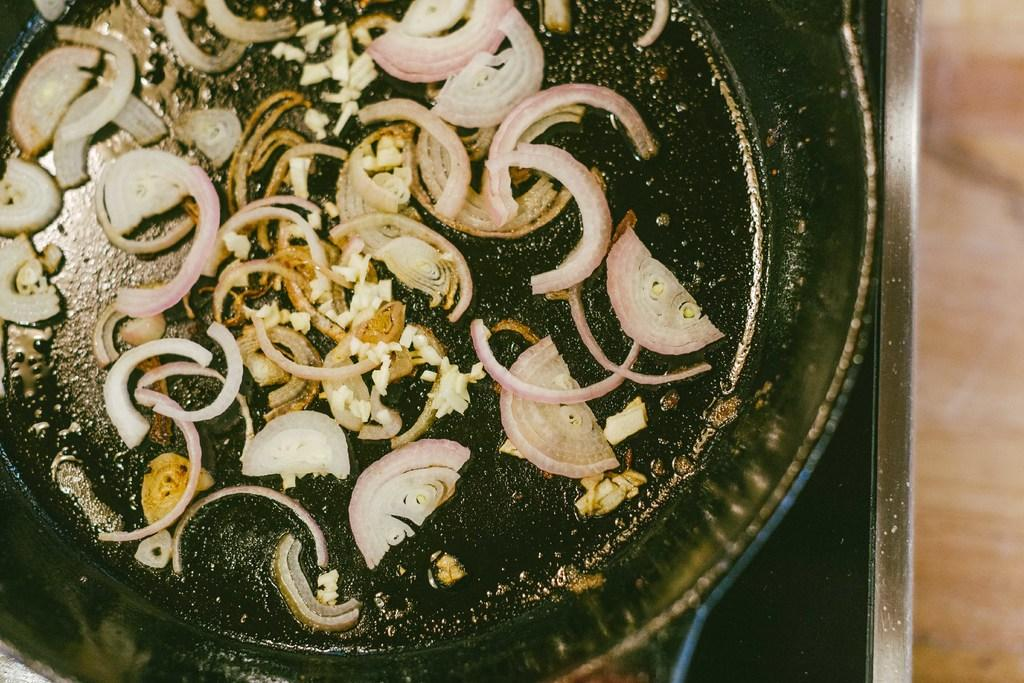What is in the pan that is visible in the image? There is a pan containing onions in the image. Where is the pan located in the image? The pan is placed on a stove in the image. What type of surface is visible beneath the stove? The floor is visible in the image. What type of goat can be seen standing on the stove in the image? There is no goat present in the image; it features a pan containing onions on a stove. 